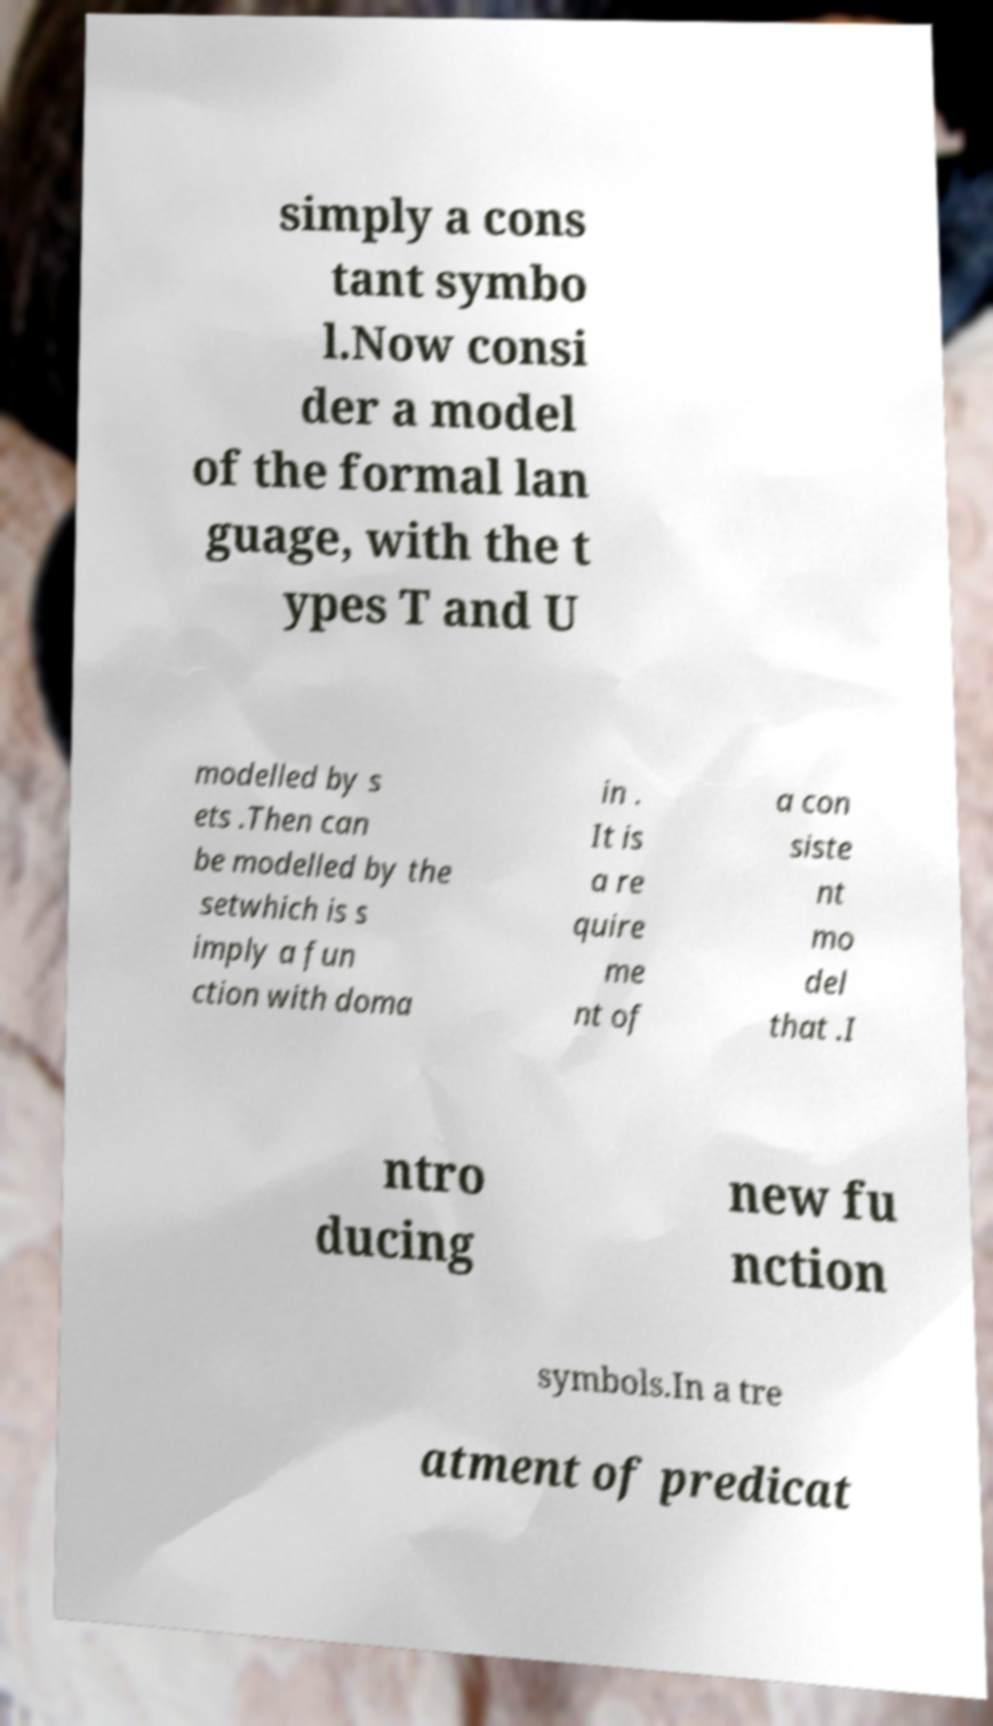Please identify and transcribe the text found in this image. simply a cons tant symbo l.Now consi der a model of the formal lan guage, with the t ypes T and U modelled by s ets .Then can be modelled by the setwhich is s imply a fun ction with doma in . It is a re quire me nt of a con siste nt mo del that .I ntro ducing new fu nction symbols.In a tre atment of predicat 